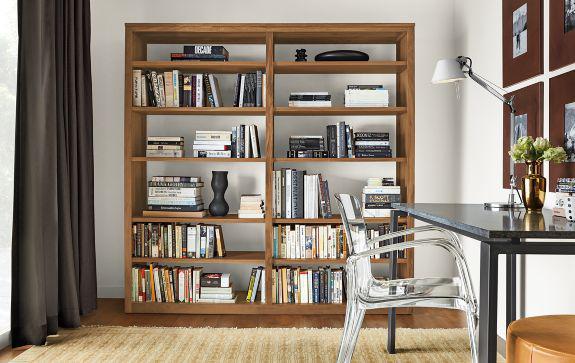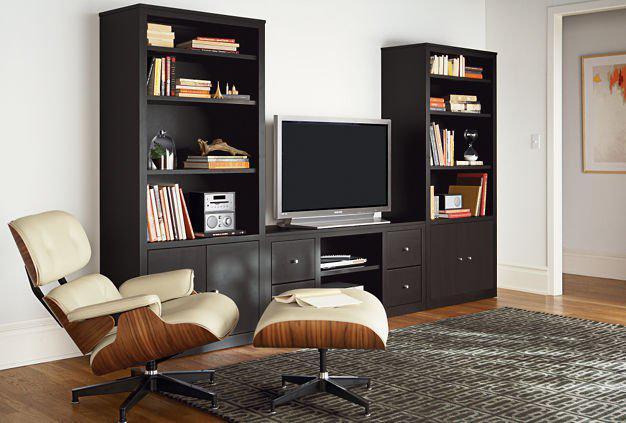The first image is the image on the left, the second image is the image on the right. Assess this claim about the two images: "A TV is sitting on a stand between two bookshelves.". Correct or not? Answer yes or no. Yes. The first image is the image on the left, the second image is the image on the right. Considering the images on both sides, is "There is a television set in between two bookcases." valid? Answer yes or no. Yes. 